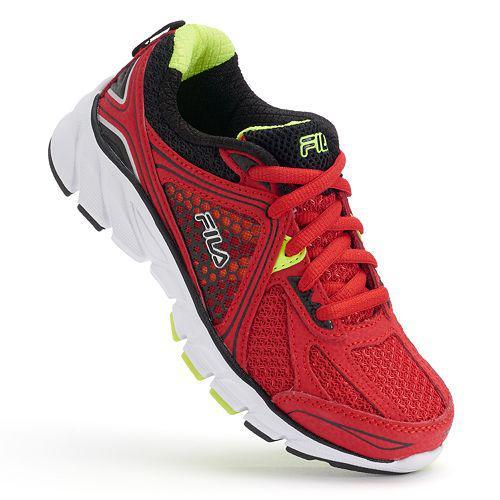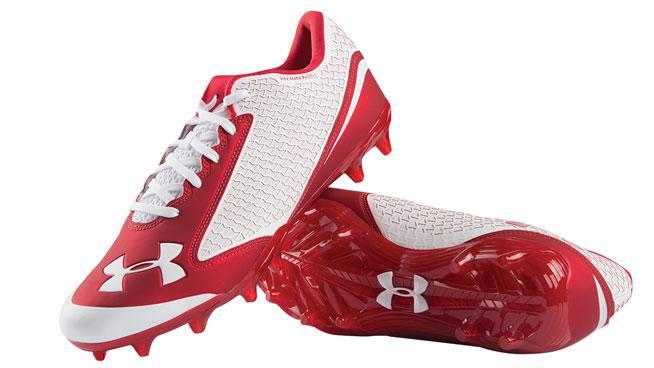The first image is the image on the left, the second image is the image on the right. For the images displayed, is the sentence "One image contains a single sneaker, and the other shows a pair of sneakers displayed with a sole-first shoe on its side and a rightside-up shoe leaning in front of it." factually correct? Answer yes or no. Yes. The first image is the image on the left, the second image is the image on the right. Given the left and right images, does the statement "One of the images is a single shoe facing left." hold true? Answer yes or no. No. 